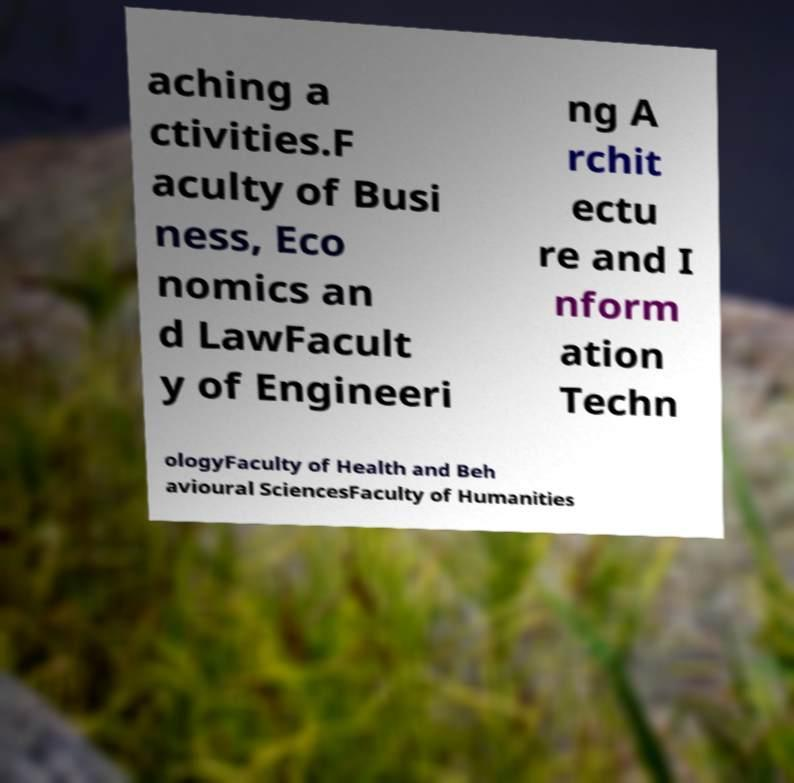Could you extract and type out the text from this image? aching a ctivities.F aculty of Busi ness, Eco nomics an d LawFacult y of Engineeri ng A rchit ectu re and I nform ation Techn ologyFaculty of Health and Beh avioural SciencesFaculty of Humanities 